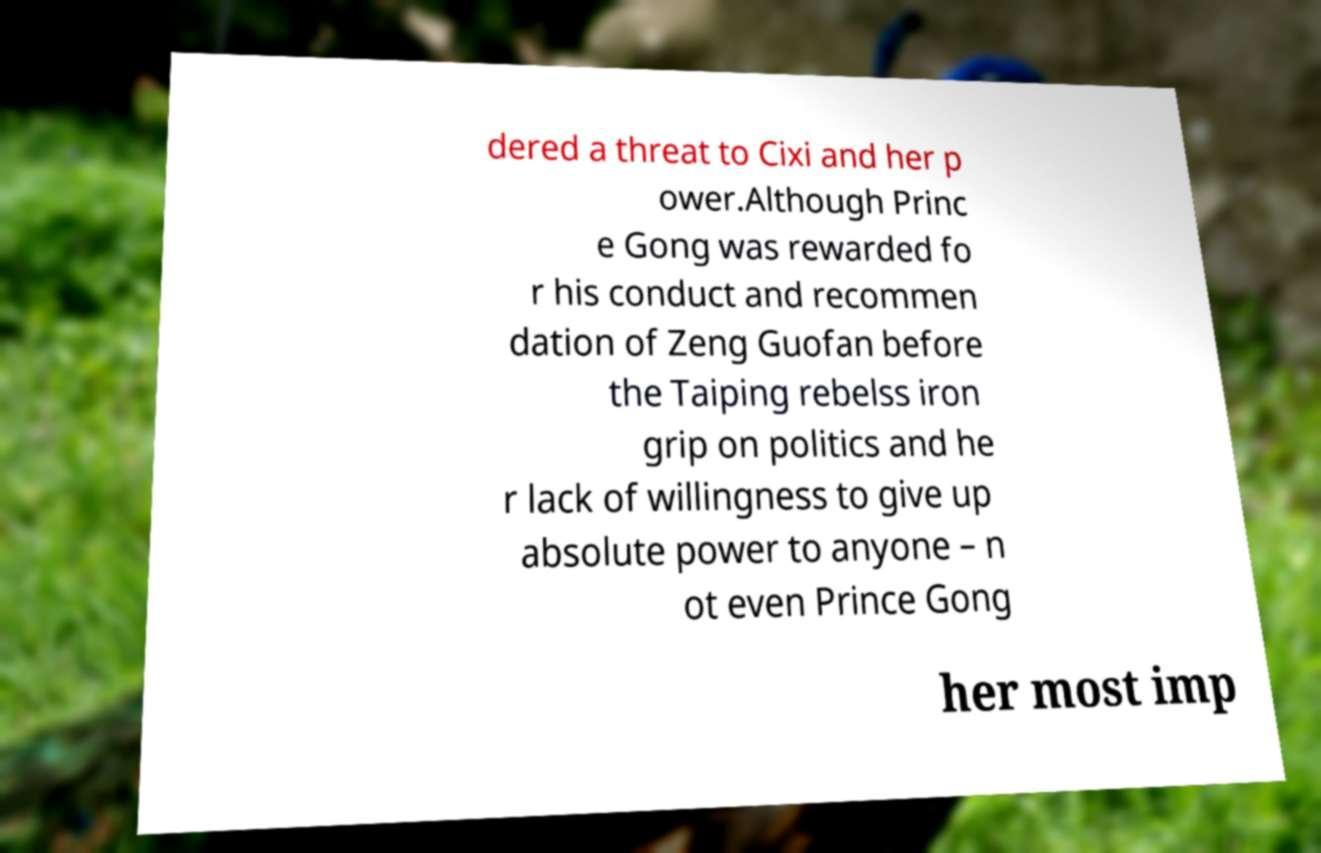For documentation purposes, I need the text within this image transcribed. Could you provide that? dered a threat to Cixi and her p ower.Although Princ e Gong was rewarded fo r his conduct and recommen dation of Zeng Guofan before the Taiping rebelss iron grip on politics and he r lack of willingness to give up absolute power to anyone – n ot even Prince Gong her most imp 